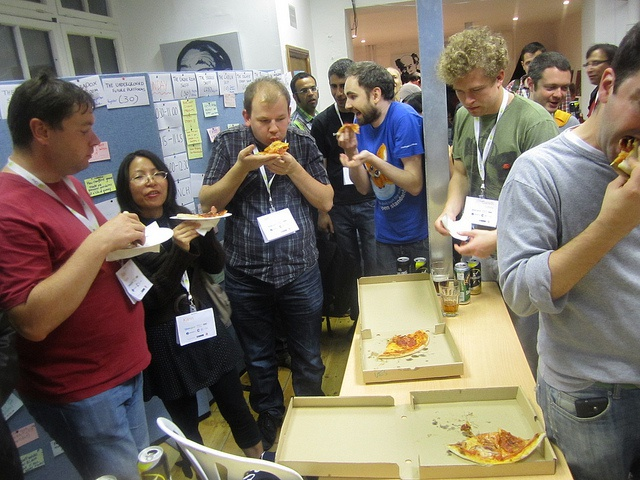Describe the objects in this image and their specific colors. I can see people in gray, maroon, black, and brown tones, people in gray, darkgray, black, and tan tones, people in gray, black, and tan tones, people in gray, black, and lavender tones, and people in gray, tan, and white tones in this image. 